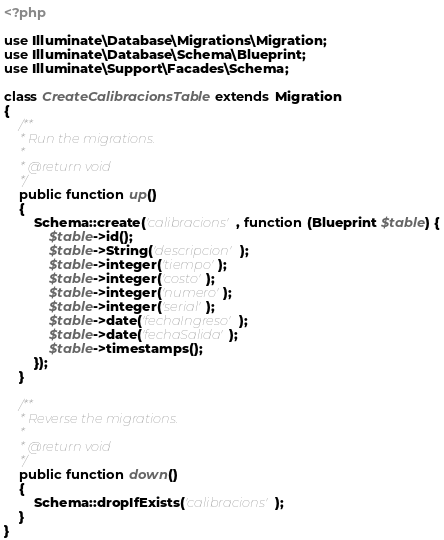<code> <loc_0><loc_0><loc_500><loc_500><_PHP_><?php

use Illuminate\Database\Migrations\Migration;
use Illuminate\Database\Schema\Blueprint;
use Illuminate\Support\Facades\Schema;

class CreateCalibracionsTable extends Migration
{
    /**
     * Run the migrations.
     *
     * @return void
     */
    public function up()
    {
        Schema::create('calibracions', function (Blueprint $table) {
            $table->id();
            $table->String('descripcion');
            $table->integer('tiempo');
            $table->integer('costo');
            $table->integer('numero');
            $table->integer('serial');
            $table->date('fechaIngreso');
            $table->date('fechaSalida');
            $table->timestamps();
        });
    }

    /**
     * Reverse the migrations.
     *
     * @return void
     */
    public function down()
    {
        Schema::dropIfExists('calibracions');
    }
}
</code> 